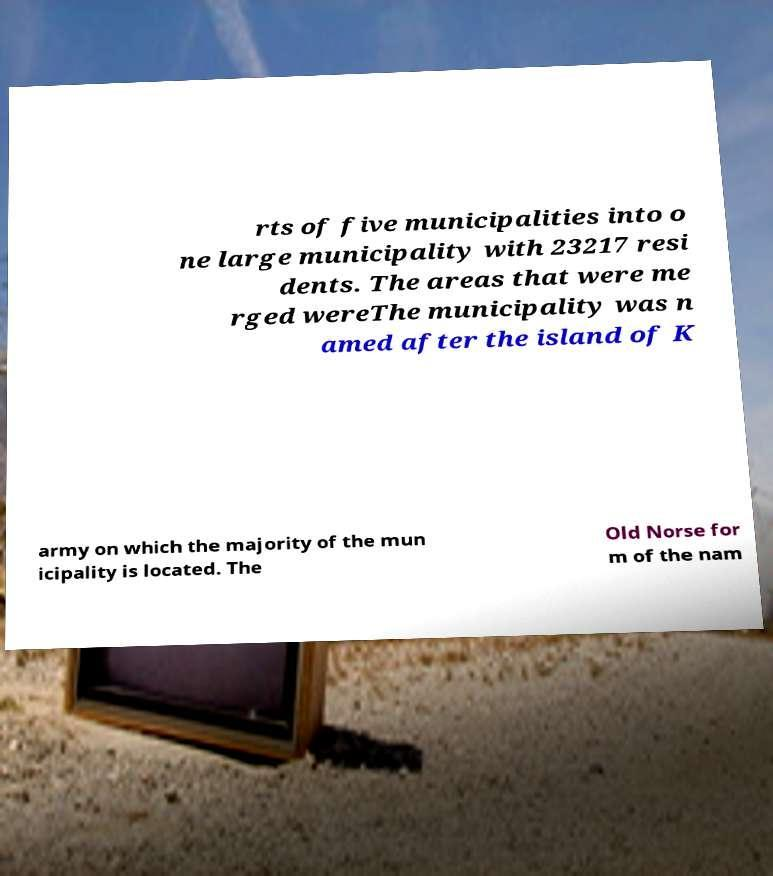There's text embedded in this image that I need extracted. Can you transcribe it verbatim? rts of five municipalities into o ne large municipality with 23217 resi dents. The areas that were me rged wereThe municipality was n amed after the island of K army on which the majority of the mun icipality is located. The Old Norse for m of the nam 